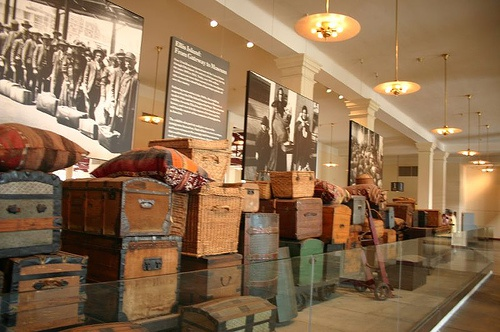Describe the objects in this image and their specific colors. I can see suitcase in tan, black, gray, brown, and maroon tones, suitcase in tan, gray, and maroon tones, suitcase in tan, black, brown, maroon, and gray tones, suitcase in tan, black, maroon, and gray tones, and suitcase in tan, gray, black, and brown tones in this image. 